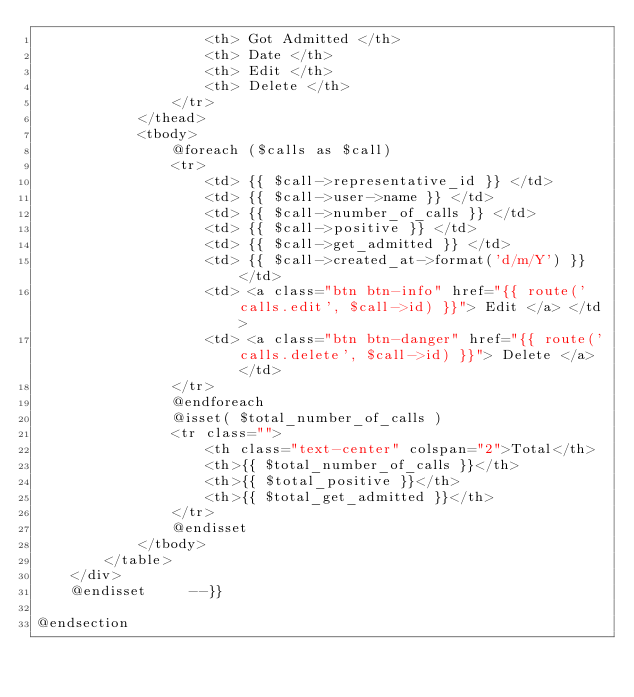<code> <loc_0><loc_0><loc_500><loc_500><_PHP_>                    <th> Got Admitted </th>    
                    <th> Date </th>
                    <th> Edit </th>    
                    <th> Delete </th>
                </tr>
            </thead>
            <tbody>
                @foreach ($calls as $call)
                <tr>
                    <td> {{ $call->representative_id }} </td>
                    <td> {{ $call->user->name }} </td>
                    <td> {{ $call->number_of_calls }} </td>
                    <td> {{ $call->positive }} </td>
                    <td> {{ $call->get_admitted }} </td>
                    <td> {{ $call->created_at->format('d/m/Y') }} </td>
                    <td> <a class="btn btn-info" href="{{ route('calls.edit', $call->id) }}"> Edit </a> </td>
                    <td> <a class="btn btn-danger" href="{{ route('calls.delete', $call->id) }}"> Delete </a> </td>
                </tr>                           
                @endforeach  
                @isset( $total_number_of_calls )
                <tr class="">
                    <th class="text-center" colspan="2">Total</th>
                    <th>{{ $total_number_of_calls }}</th>
                    <th>{{ $total_positive }}</th>
                    <th>{{ $total_get_admitted }}</th>
                </tr>         
                @endisset
            </tbody>
        </table>
    </div>
    @endisset     --}}

@endsection
</code> 